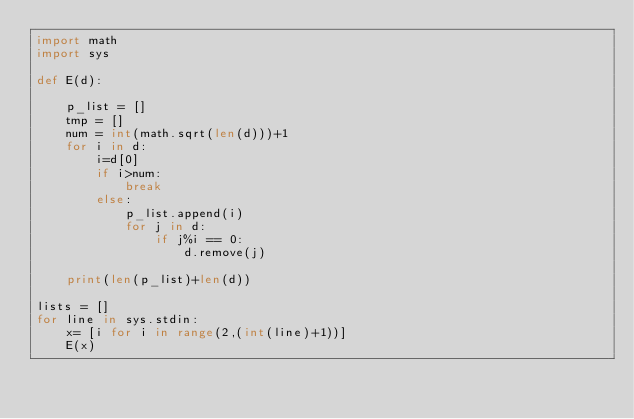<code> <loc_0><loc_0><loc_500><loc_500><_Python_>import math
import sys

def E(d):

    p_list = [] 
    tmp = []
    num = int(math.sqrt(len(d)))+1
    for i in d:
        i=d[0]
        if i>num:
            break
        else:
            p_list.append(i)
            for j in d:
                if j%i == 0:
                    d.remove(j)
        
    print(len(p_list)+len(d))

lists = []
for line in sys.stdin:
    x= [i for i in range(2,(int(line)+1))]
    E(x)</code> 